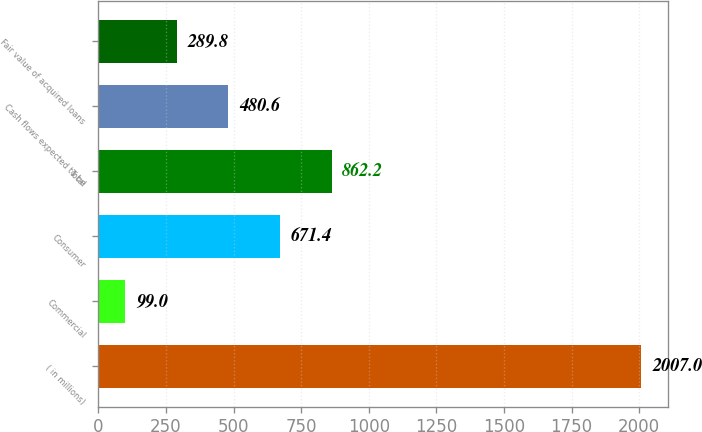Convert chart. <chart><loc_0><loc_0><loc_500><loc_500><bar_chart><fcel>( in millions)<fcel>Commercial<fcel>Consumer<fcel>Total<fcel>Cash flows expected to be<fcel>Fair value of acquired loans<nl><fcel>2007<fcel>99<fcel>671.4<fcel>862.2<fcel>480.6<fcel>289.8<nl></chart> 